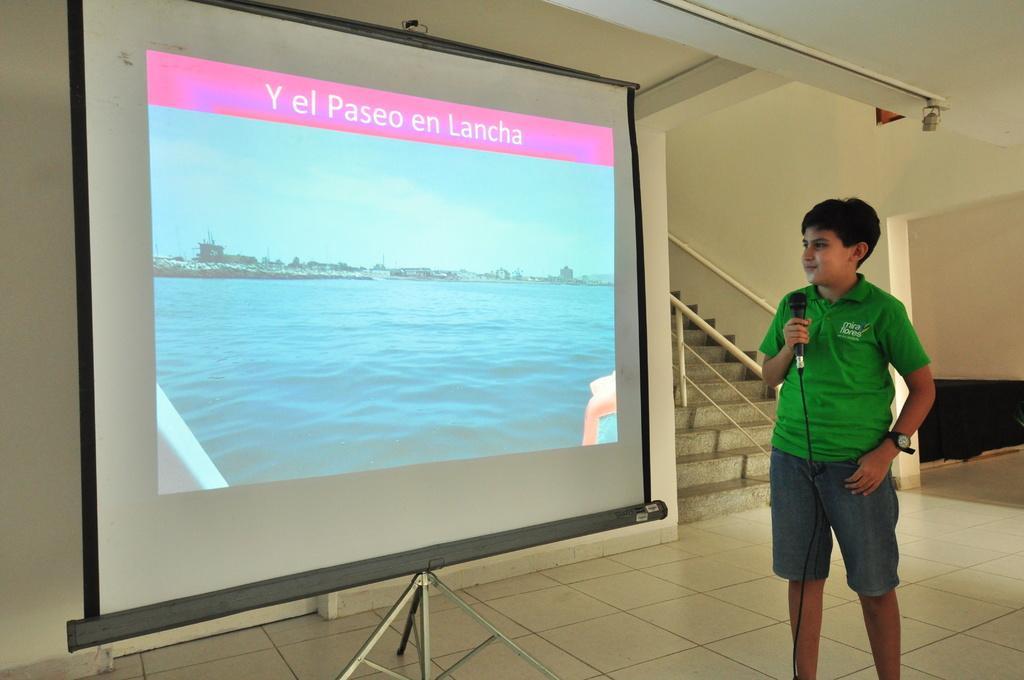Describe this image in one or two sentences. In this image I can see a boy is standing and holding a microphone in the hand. Here I can see a projector screen, on the screen I can see water, the sky and buildings. Here I can see stairs and ceiling. 